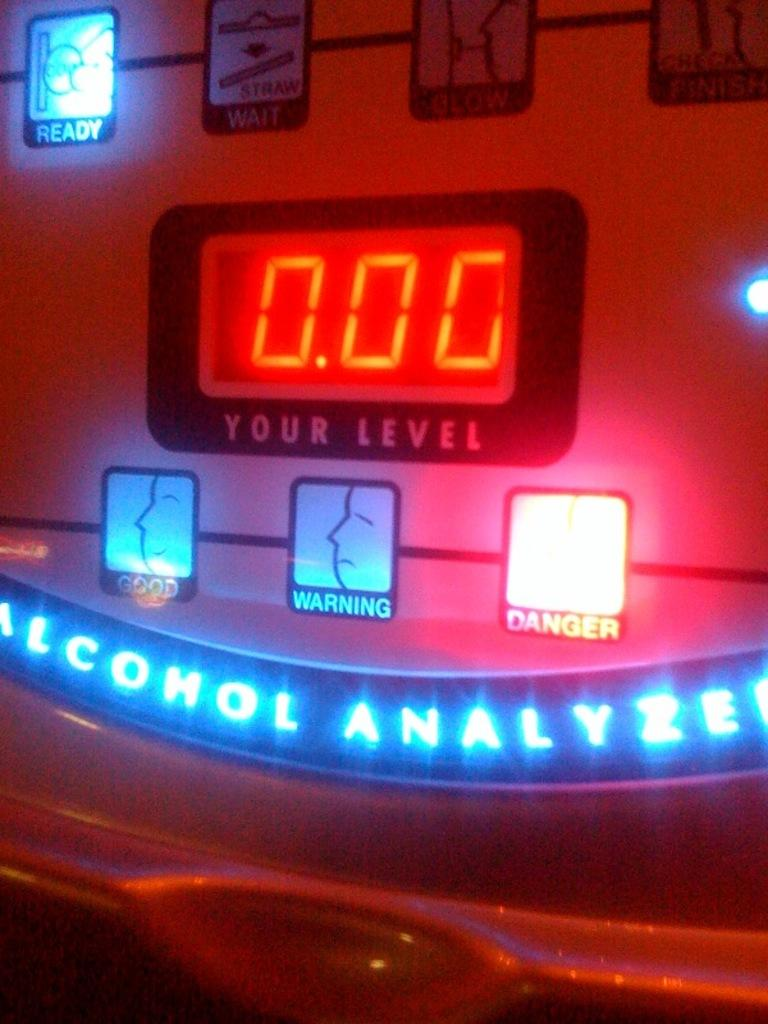<image>
Give a short and clear explanation of the subsequent image. A coin operated alcohol analyzer with various faces depicting warning levels and a digitial display for numerical values. 